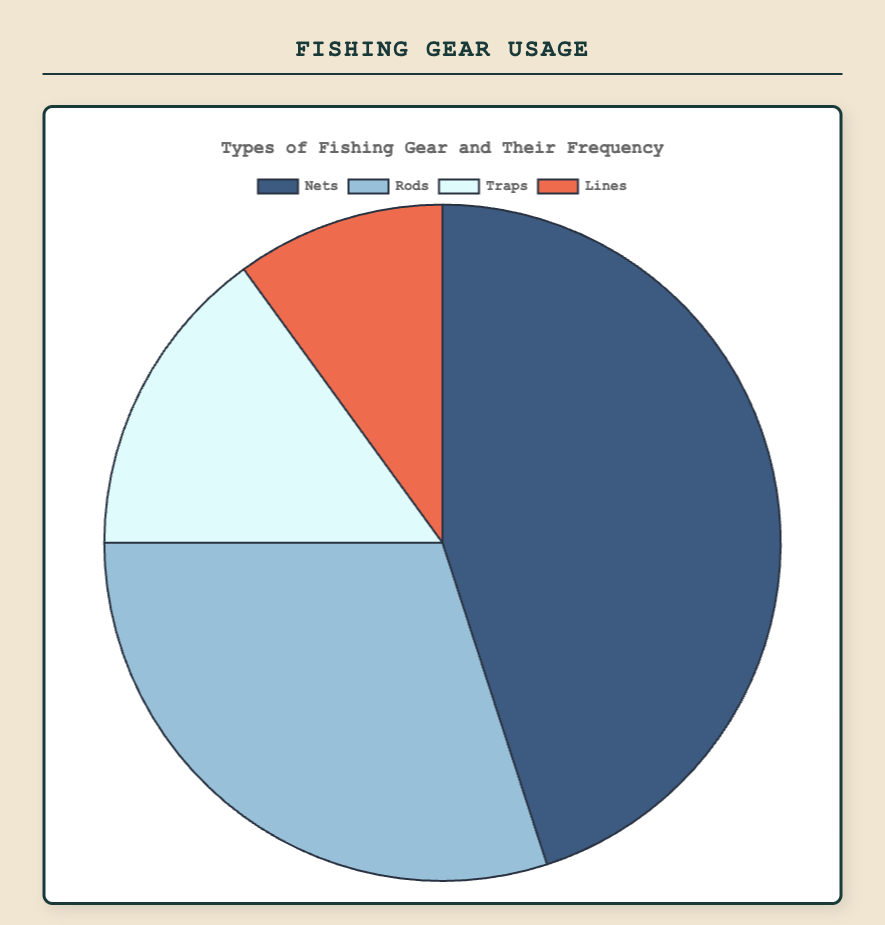Which type of fishing gear is used the most? The pie chart shows four types of fishing gear, with "Nets" occupying the largest section. "Nets" have the highest frequency with 45.
Answer: Nets Which type of fishing gear is used the least? Looking at the smallest section of the pie chart, "Lines" have the smallest share with a frequency of 10.
Answer: Lines What are the combined frequencies of Traps and Lines? Adding the frequencies of "Traps" and "Lines": 15 + 10 = 25.
Answer: 25 Is the usage of Nets greater than Rods and Traps combined? The frequency for "Nets" is 45. Combined frequencies of "Rods" (30) and "Traps" (15) add up to 45. 45 is equal to 45, so usage is not greater.
Answer: No How much higher is the usage of Nets compared to Lines? Subtract the frequency of "Lines" from "Nets": 45 - 10 = 35.
Answer: 35 Which color represents the fishing gear used the least? The section with the lowest frequency (Lines) is represented by the color orange.
Answer: Orange How does the usage of Rods compare to the usage of Traps? "Rods" have a frequency of 30, whereas "Traps" have a frequency of 15. 30 is twice as much as 15.
Answer: Rods are used twice as much as Traps What percentage of the total does the usage of Nets constitute? The total frequency is 45 (Nets) + 30 (Rods) + 15 (Traps) + 10 (Lines) = 100. The percentage for "Nets" is (45/100) * 100% = 45%.
Answer: 45% What is the average frequency of all fishing gear types? The total frequency of all types is 100. There are 4 types, so the average frequency is 100 / 4 = 25.
Answer: 25 If the usage of Traps doubled, would it surpass the usage of Rods? Doubling "Traps" frequency: 15 * 2 = 30. The frequency of "Rods" is also 30. Since they are equal, "Traps" would not surpass "Rods".
Answer: No 